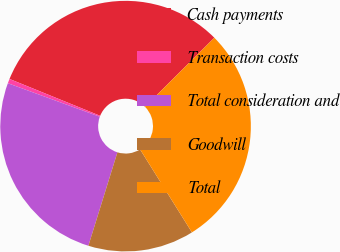Convert chart to OTSL. <chart><loc_0><loc_0><loc_500><loc_500><pie_chart><fcel>Cash payments<fcel>Transaction costs<fcel>Total consideration and<fcel>Goodwill<fcel>Total<nl><fcel>31.39%<fcel>0.58%<fcel>25.77%<fcel>13.68%<fcel>28.58%<nl></chart> 